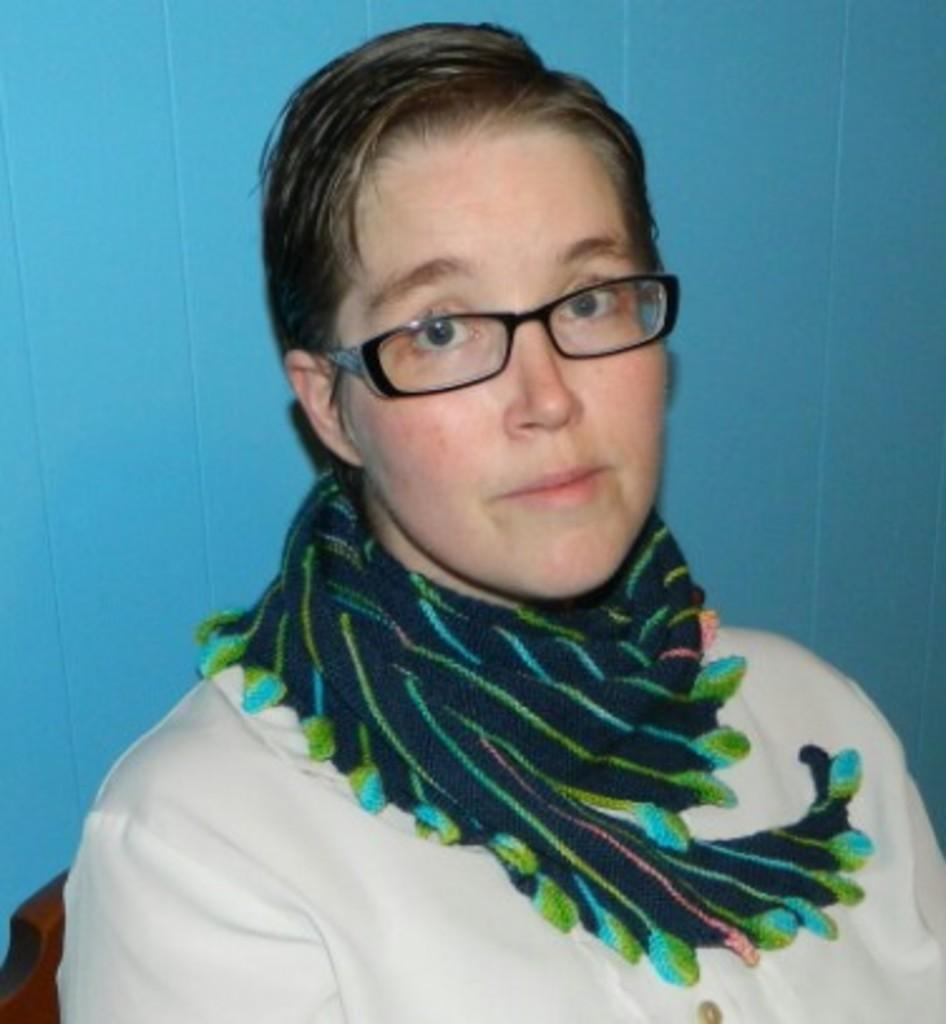What is the main subject of the image? The main subject of the image is a woman. What can be observed about the woman's attire? The woman is wearing clothes, a scarf, and spectacles. What color is the background of the image? The background of the image is blue. What type of cabbage is placed in the vase in the image? There is no cabbage or vase present in the image; it is a close-up of a woman. Can you tell me where the church is located in the image? There is no church present in the image; it is a close-up of a woman. 